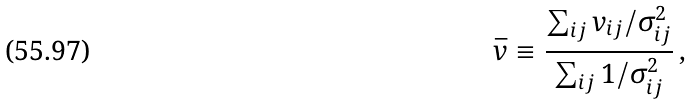Convert formula to latex. <formula><loc_0><loc_0><loc_500><loc_500>\bar { v } \equiv \frac { \sum _ { i j } v _ { i j } / \sigma ^ { 2 } _ { i j } } { \sum _ { i j } 1 / \sigma ^ { 2 } _ { i j } } \, ,</formula> 